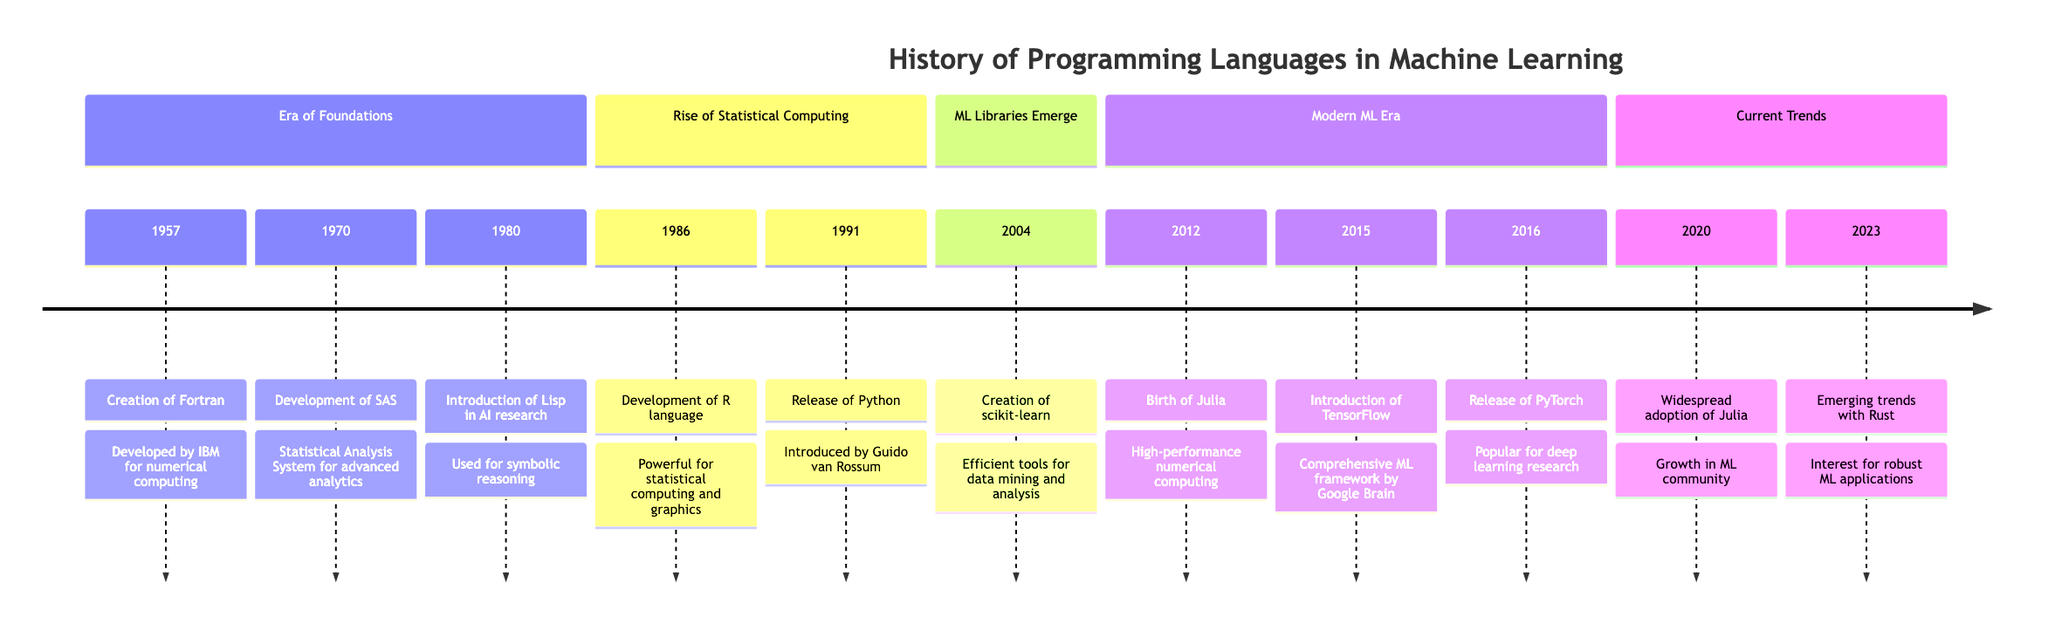What year was Fortran created? The diagram indicates that Fortran was created in 1957, as it is the first event listed in the "Era of Foundations" section.
Answer: 1957 What programming language was released in 1991? According to the timeline, Python was released in 1991. This is clearly stated as the second event in the "Rise of Statistical Computing" section.
Answer: Python Which language was introduced for high-performance numerical computing in 2012? The timeline states that Julia was created in 2012 specifically to address the need for high-performance numerical computing. This information is located in the "Modern ML Era" section.
Answer: Julia How many events are listed in the "Current Trends" section? The "Current Trends" section contains two events: one in 2020 regarding Julia and another in 2023 regarding Rust. Thus, counting these two provides the answer.
Answer: 2 What is the significance of TensorFlow in 2015? The diagram specifies that TensorFlow was introduced in 2015 by Google Brain and indicates it significantly boosted Python's adoption in the ML community. This is detailed in the "Modern ML Era" section.
Answer: Boosted Python adoption Which language gained prominence for AI research in 1980? The timeline notes that Lisp gained traction in the AI research community due to its suitability for symbolic reasoning and problem-solving tasks, making it the answer for this question.
Answer: Lisp Name a language that became a staple for data analysis and machine learning methods after 1986. The event from the diagram in 1986 indicates that R emerged as a powerful language for statistical computing, making it a staple for data analysis and machine learning thereafter.
Answer: R What programming language was developed alongside the rise of ML libraries in 2004? The timeline identifies scikit-learn, developed in 2004 and providing tools for data mining, as significant within the context of Python's ecosystem for machine learning, therefore, it is the answer to this question.
Answer: scikit-learn 